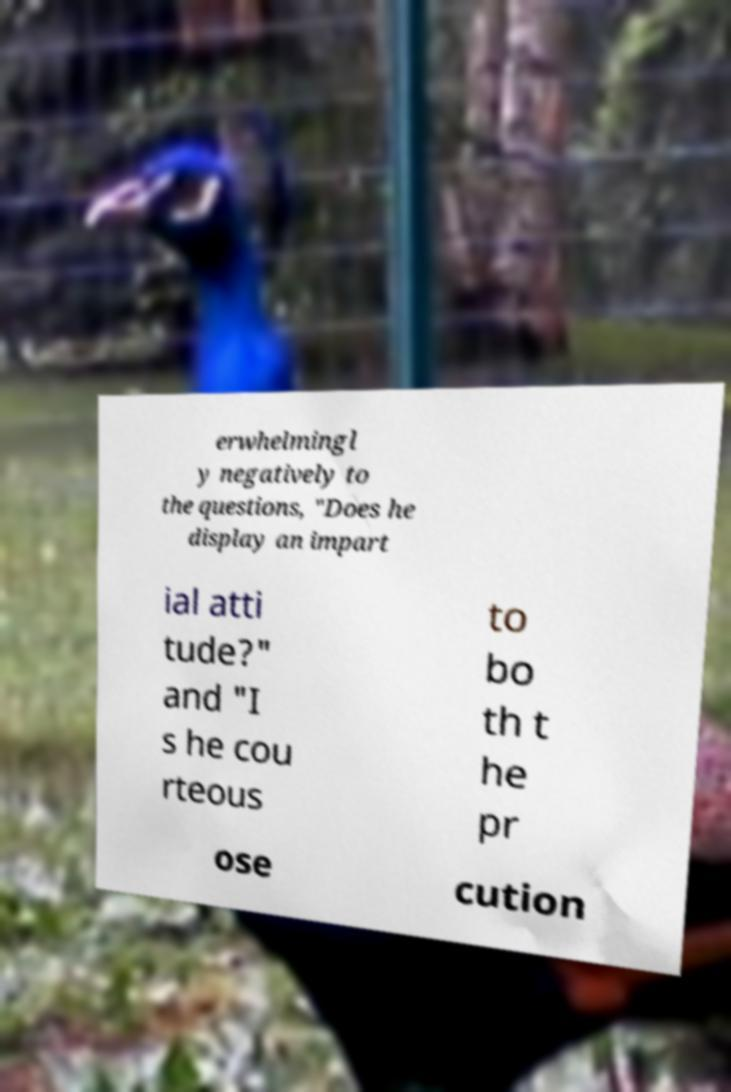Could you extract and type out the text from this image? erwhelmingl y negatively to the questions, "Does he display an impart ial atti tude?" and "I s he cou rteous to bo th t he pr ose cution 